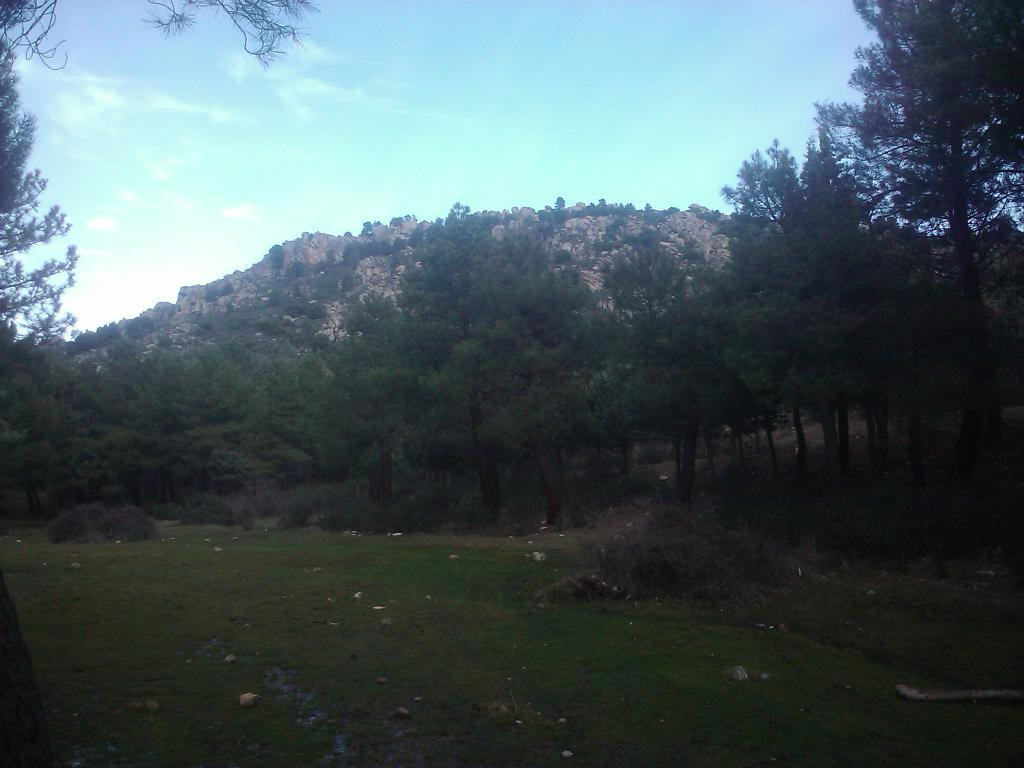What type of surface can be seen in the image? There is ground visible in the image. What is present on the ground in the image? There are objects on the ground. What type of vegetation is in the image? There is grass, trees, and plants in the image. What type of terrain is visible in the image? There are hills in the image. What is visible in the sky in the image? The sky is visible in the image, and there are clouds in the sky. What type of joke is being told by the wren in the image? There is no wren present in the image, and therefore no joke being told. 